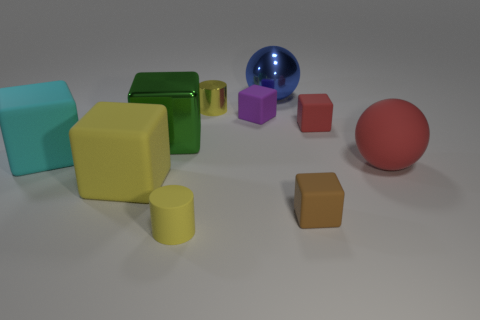Is the color of the big metal thing in front of the purple thing the same as the sphere to the left of the big red matte object?
Your response must be concise. No. Is the number of blue shiny spheres less than the number of tiny cylinders?
Give a very brief answer. Yes. What shape is the red object that is in front of the thing on the left side of the big yellow object?
Provide a succinct answer. Sphere. Are there any other things that have the same size as the red matte cube?
Offer a terse response. Yes. The yellow object that is to the left of the cylinder that is in front of the small cylinder behind the large yellow rubber thing is what shape?
Offer a terse response. Cube. What number of objects are big cubes that are on the left side of the big green cube or big spheres in front of the metal cube?
Keep it short and to the point. 3. Is the size of the brown block the same as the green cube left of the blue metallic sphere?
Your answer should be very brief. No. Does the tiny yellow cylinder that is behind the matte ball have the same material as the large sphere behind the purple object?
Your answer should be very brief. Yes. Are there the same number of small red cubes on the left side of the big yellow cube and small rubber cylinders on the right side of the small shiny cylinder?
Keep it short and to the point. Yes. What number of rubber cylinders are the same color as the small metallic thing?
Provide a short and direct response. 1. 